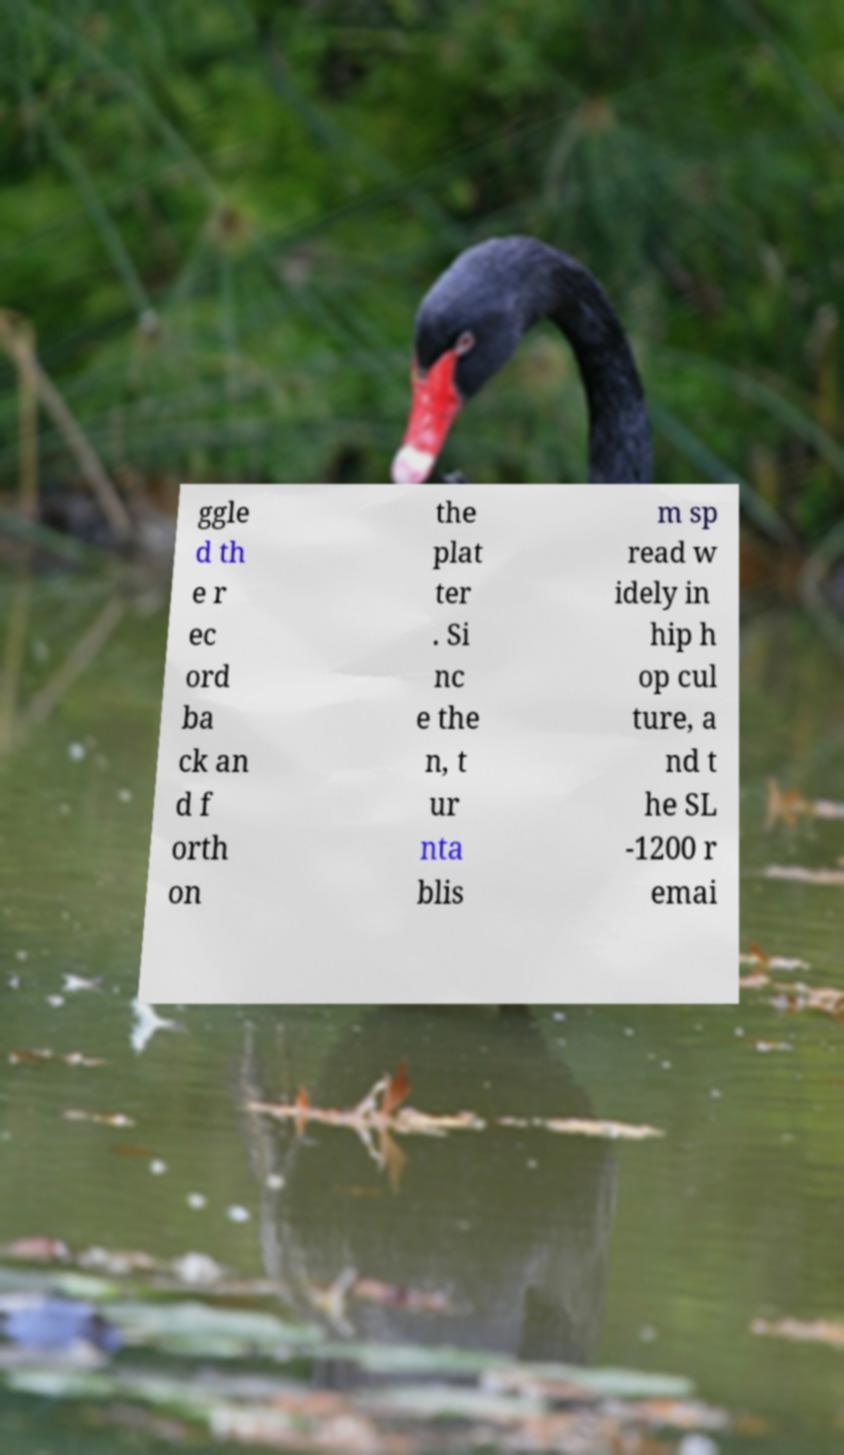I need the written content from this picture converted into text. Can you do that? ggle d th e r ec ord ba ck an d f orth on the plat ter . Si nc e the n, t ur nta blis m sp read w idely in hip h op cul ture, a nd t he SL -1200 r emai 